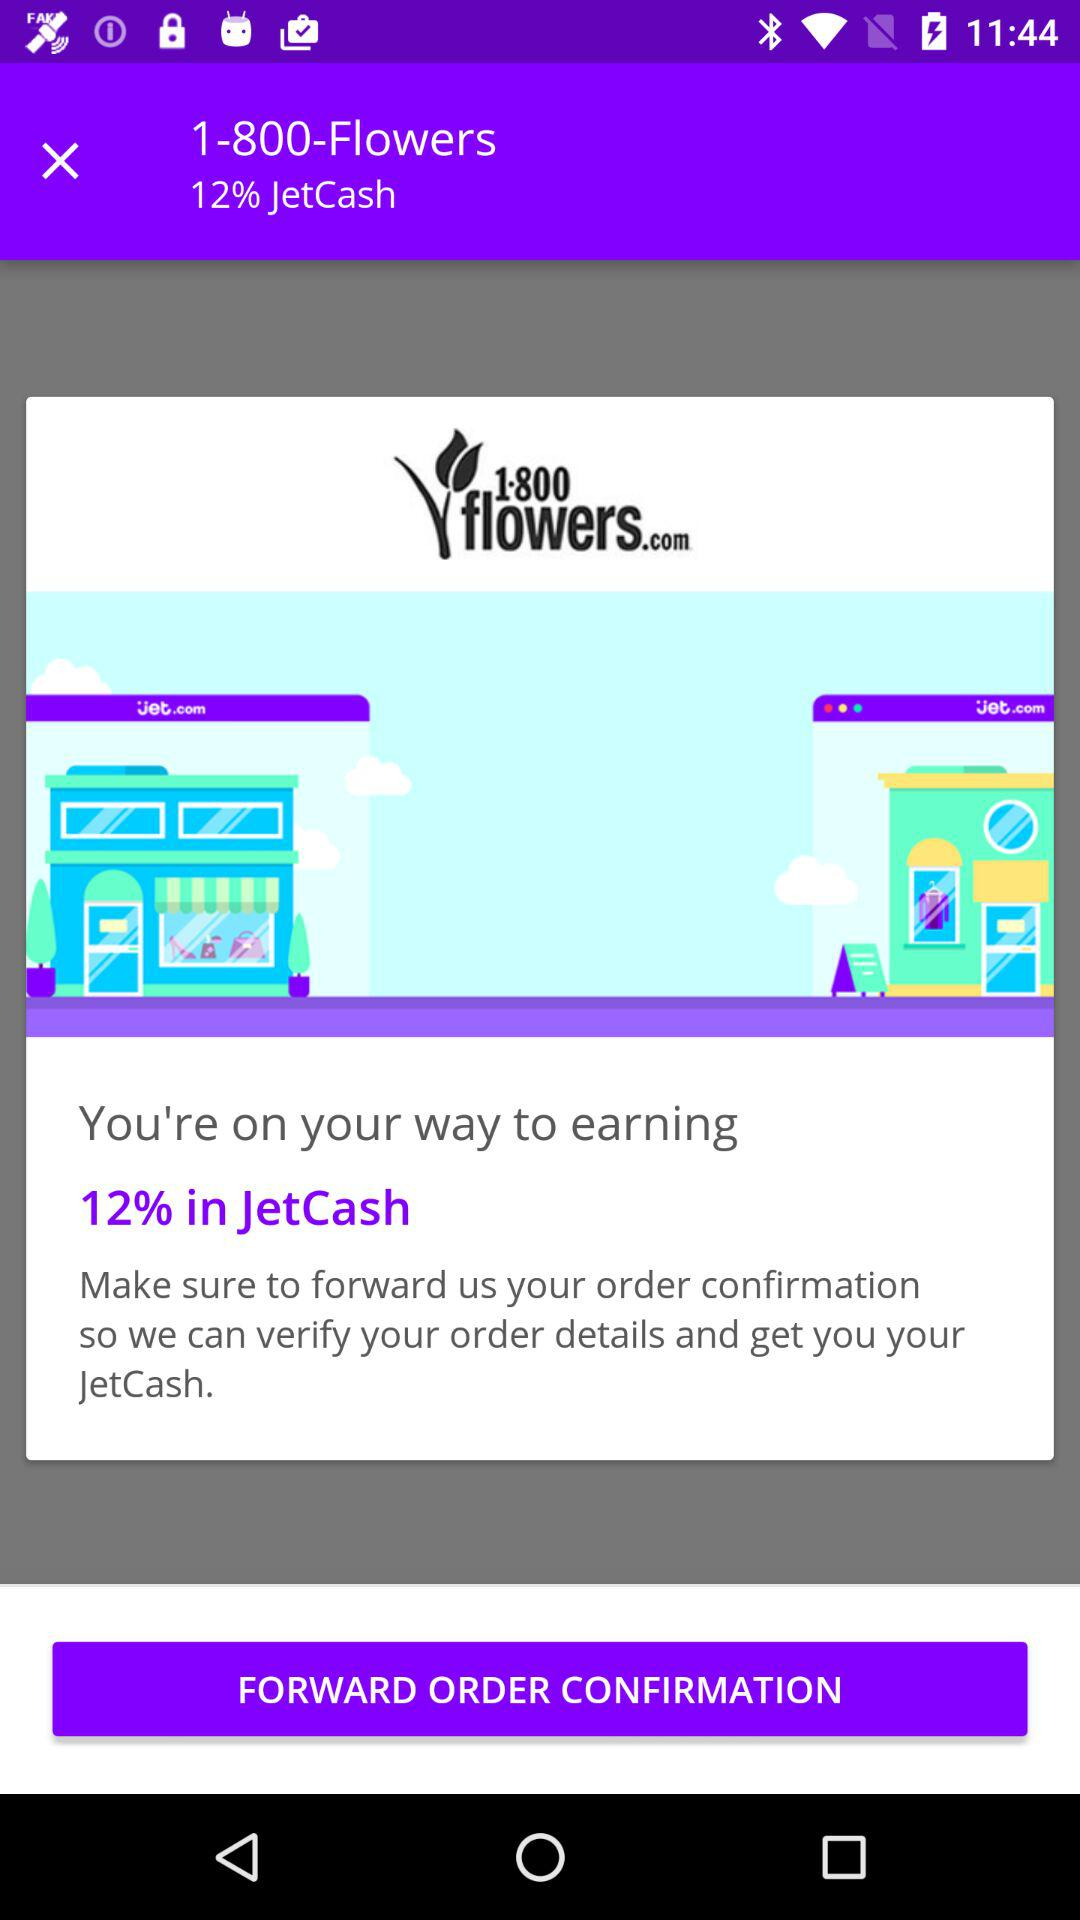What percentage of "JetCash" will I earn on forwarding the order confirmation? You will earn 12% of "JetCash" on forwarding the order confirmation. 